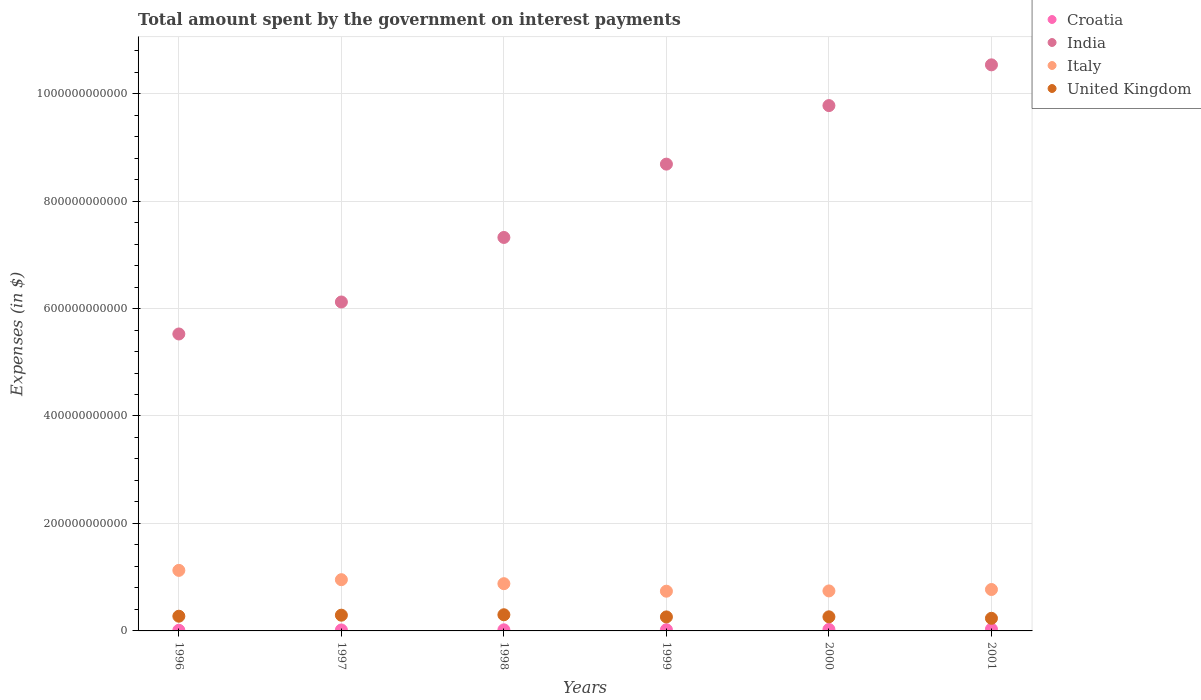Is the number of dotlines equal to the number of legend labels?
Provide a succinct answer. Yes. What is the amount spent on interest payments by the government in Italy in 1999?
Provide a succinct answer. 7.39e+1. Across all years, what is the maximum amount spent on interest payments by the government in Italy?
Your answer should be compact. 1.13e+11. Across all years, what is the minimum amount spent on interest payments by the government in India?
Provide a short and direct response. 5.53e+11. In which year was the amount spent on interest payments by the government in India maximum?
Give a very brief answer. 2001. What is the total amount spent on interest payments by the government in Croatia in the graph?
Make the answer very short. 1.33e+1. What is the difference between the amount spent on interest payments by the government in Italy in 1996 and that in 1998?
Keep it short and to the point. 2.47e+1. What is the difference between the amount spent on interest payments by the government in Croatia in 1997 and the amount spent on interest payments by the government in India in 2000?
Offer a terse response. -9.76e+11. What is the average amount spent on interest payments by the government in United Kingdom per year?
Provide a short and direct response. 2.71e+1. In the year 1996, what is the difference between the amount spent on interest payments by the government in Croatia and amount spent on interest payments by the government in India?
Keep it short and to the point. -5.51e+11. What is the ratio of the amount spent on interest payments by the government in India in 1996 to that in 2000?
Keep it short and to the point. 0.57. Is the amount spent on interest payments by the government in United Kingdom in 1998 less than that in 1999?
Offer a very short reply. No. What is the difference between the highest and the second highest amount spent on interest payments by the government in United Kingdom?
Your answer should be compact. 7.84e+08. What is the difference between the highest and the lowest amount spent on interest payments by the government in Italy?
Make the answer very short. 3.88e+1. Is it the case that in every year, the sum of the amount spent on interest payments by the government in United Kingdom and amount spent on interest payments by the government in Italy  is greater than the amount spent on interest payments by the government in Croatia?
Provide a short and direct response. Yes. Does the amount spent on interest payments by the government in Croatia monotonically increase over the years?
Your response must be concise. Yes. Is the amount spent on interest payments by the government in Italy strictly greater than the amount spent on interest payments by the government in Croatia over the years?
Give a very brief answer. Yes. What is the difference between two consecutive major ticks on the Y-axis?
Offer a terse response. 2.00e+11. Are the values on the major ticks of Y-axis written in scientific E-notation?
Offer a very short reply. No. Does the graph contain any zero values?
Offer a terse response. No. Does the graph contain grids?
Your answer should be very brief. Yes. Where does the legend appear in the graph?
Your response must be concise. Top right. What is the title of the graph?
Provide a short and direct response. Total amount spent by the government on interest payments. What is the label or title of the X-axis?
Your answer should be compact. Years. What is the label or title of the Y-axis?
Make the answer very short. Expenses (in $). What is the Expenses (in $) in Croatia in 1996?
Your answer should be very brief. 1.23e+09. What is the Expenses (in $) in India in 1996?
Offer a terse response. 5.53e+11. What is the Expenses (in $) in Italy in 1996?
Your answer should be very brief. 1.13e+11. What is the Expenses (in $) in United Kingdom in 1996?
Offer a terse response. 2.74e+1. What is the Expenses (in $) of Croatia in 1997?
Make the answer very short. 1.79e+09. What is the Expenses (in $) of India in 1997?
Your response must be concise. 6.12e+11. What is the Expenses (in $) of Italy in 1997?
Ensure brevity in your answer.  9.54e+1. What is the Expenses (in $) of United Kingdom in 1997?
Your response must be concise. 2.93e+1. What is the Expenses (in $) of Croatia in 1998?
Offer a terse response. 2.03e+09. What is the Expenses (in $) in India in 1998?
Your answer should be compact. 7.32e+11. What is the Expenses (in $) of Italy in 1998?
Your answer should be very brief. 8.79e+1. What is the Expenses (in $) in United Kingdom in 1998?
Offer a terse response. 3.01e+1. What is the Expenses (in $) in Croatia in 1999?
Give a very brief answer. 2.23e+09. What is the Expenses (in $) in India in 1999?
Your answer should be very brief. 8.69e+11. What is the Expenses (in $) of Italy in 1999?
Keep it short and to the point. 7.39e+1. What is the Expenses (in $) of United Kingdom in 1999?
Your answer should be compact. 2.61e+1. What is the Expenses (in $) of Croatia in 2000?
Make the answer very short. 2.76e+09. What is the Expenses (in $) of India in 2000?
Make the answer very short. 9.78e+11. What is the Expenses (in $) in Italy in 2000?
Give a very brief answer. 7.44e+1. What is the Expenses (in $) of United Kingdom in 2000?
Offer a terse response. 2.62e+1. What is the Expenses (in $) of Croatia in 2001?
Your answer should be very brief. 3.26e+09. What is the Expenses (in $) of India in 2001?
Provide a short and direct response. 1.05e+12. What is the Expenses (in $) in Italy in 2001?
Offer a very short reply. 7.71e+1. What is the Expenses (in $) in United Kingdom in 2001?
Your answer should be very brief. 2.35e+1. Across all years, what is the maximum Expenses (in $) of Croatia?
Provide a succinct answer. 3.26e+09. Across all years, what is the maximum Expenses (in $) of India?
Your answer should be very brief. 1.05e+12. Across all years, what is the maximum Expenses (in $) of Italy?
Provide a succinct answer. 1.13e+11. Across all years, what is the maximum Expenses (in $) of United Kingdom?
Ensure brevity in your answer.  3.01e+1. Across all years, what is the minimum Expenses (in $) of Croatia?
Give a very brief answer. 1.23e+09. Across all years, what is the minimum Expenses (in $) of India?
Keep it short and to the point. 5.53e+11. Across all years, what is the minimum Expenses (in $) of Italy?
Your response must be concise. 7.39e+1. Across all years, what is the minimum Expenses (in $) in United Kingdom?
Provide a short and direct response. 2.35e+1. What is the total Expenses (in $) in Croatia in the graph?
Make the answer very short. 1.33e+1. What is the total Expenses (in $) in India in the graph?
Your answer should be compact. 4.80e+12. What is the total Expenses (in $) in Italy in the graph?
Offer a terse response. 5.21e+11. What is the total Expenses (in $) of United Kingdom in the graph?
Provide a succinct answer. 1.63e+11. What is the difference between the Expenses (in $) in Croatia in 1996 and that in 1997?
Ensure brevity in your answer.  -5.56e+08. What is the difference between the Expenses (in $) of India in 1996 and that in 1997?
Keep it short and to the point. -5.95e+1. What is the difference between the Expenses (in $) in Italy in 1996 and that in 1997?
Provide a succinct answer. 1.73e+1. What is the difference between the Expenses (in $) in United Kingdom in 1996 and that in 1997?
Keep it short and to the point. -1.93e+09. What is the difference between the Expenses (in $) of Croatia in 1996 and that in 1998?
Provide a succinct answer. -7.92e+08. What is the difference between the Expenses (in $) in India in 1996 and that in 1998?
Keep it short and to the point. -1.80e+11. What is the difference between the Expenses (in $) of Italy in 1996 and that in 1998?
Make the answer very short. 2.47e+1. What is the difference between the Expenses (in $) in United Kingdom in 1996 and that in 1998?
Ensure brevity in your answer.  -2.71e+09. What is the difference between the Expenses (in $) of Croatia in 1996 and that in 1999?
Your answer should be compact. -9.93e+08. What is the difference between the Expenses (in $) of India in 1996 and that in 1999?
Your answer should be compact. -3.16e+11. What is the difference between the Expenses (in $) in Italy in 1996 and that in 1999?
Offer a terse response. 3.88e+1. What is the difference between the Expenses (in $) in United Kingdom in 1996 and that in 1999?
Your answer should be very brief. 1.29e+09. What is the difference between the Expenses (in $) in Croatia in 1996 and that in 2000?
Your answer should be very brief. -1.53e+09. What is the difference between the Expenses (in $) of India in 1996 and that in 2000?
Offer a terse response. -4.25e+11. What is the difference between the Expenses (in $) of Italy in 1996 and that in 2000?
Give a very brief answer. 3.82e+1. What is the difference between the Expenses (in $) of United Kingdom in 1996 and that in 2000?
Make the answer very short. 1.13e+09. What is the difference between the Expenses (in $) of Croatia in 1996 and that in 2001?
Provide a succinct answer. -2.03e+09. What is the difference between the Expenses (in $) of India in 1996 and that in 2001?
Ensure brevity in your answer.  -5.01e+11. What is the difference between the Expenses (in $) of Italy in 1996 and that in 2001?
Offer a very short reply. 3.56e+1. What is the difference between the Expenses (in $) in United Kingdom in 1996 and that in 2001?
Your answer should be very brief. 3.89e+09. What is the difference between the Expenses (in $) in Croatia in 1997 and that in 1998?
Offer a terse response. -2.35e+08. What is the difference between the Expenses (in $) of India in 1997 and that in 1998?
Your answer should be compact. -1.20e+11. What is the difference between the Expenses (in $) in Italy in 1997 and that in 1998?
Keep it short and to the point. 7.42e+09. What is the difference between the Expenses (in $) in United Kingdom in 1997 and that in 1998?
Your answer should be compact. -7.84e+08. What is the difference between the Expenses (in $) in Croatia in 1997 and that in 1999?
Make the answer very short. -4.36e+08. What is the difference between the Expenses (in $) in India in 1997 and that in 1999?
Your response must be concise. -2.57e+11. What is the difference between the Expenses (in $) in Italy in 1997 and that in 1999?
Provide a short and direct response. 2.14e+1. What is the difference between the Expenses (in $) in United Kingdom in 1997 and that in 1999?
Provide a short and direct response. 3.22e+09. What is the difference between the Expenses (in $) of Croatia in 1997 and that in 2000?
Your answer should be very brief. -9.73e+08. What is the difference between the Expenses (in $) of India in 1997 and that in 2000?
Your response must be concise. -3.66e+11. What is the difference between the Expenses (in $) of Italy in 1997 and that in 2000?
Keep it short and to the point. 2.09e+1. What is the difference between the Expenses (in $) in United Kingdom in 1997 and that in 2000?
Ensure brevity in your answer.  3.06e+09. What is the difference between the Expenses (in $) in Croatia in 1997 and that in 2001?
Ensure brevity in your answer.  -1.47e+09. What is the difference between the Expenses (in $) in India in 1997 and that in 2001?
Give a very brief answer. -4.41e+11. What is the difference between the Expenses (in $) of Italy in 1997 and that in 2001?
Ensure brevity in your answer.  1.83e+1. What is the difference between the Expenses (in $) of United Kingdom in 1997 and that in 2001?
Provide a short and direct response. 5.82e+09. What is the difference between the Expenses (in $) of Croatia in 1998 and that in 1999?
Offer a very short reply. -2.01e+08. What is the difference between the Expenses (in $) in India in 1998 and that in 1999?
Provide a short and direct response. -1.36e+11. What is the difference between the Expenses (in $) of Italy in 1998 and that in 1999?
Your answer should be compact. 1.40e+1. What is the difference between the Expenses (in $) in United Kingdom in 1998 and that in 1999?
Ensure brevity in your answer.  4.01e+09. What is the difference between the Expenses (in $) in Croatia in 1998 and that in 2000?
Provide a short and direct response. -7.38e+08. What is the difference between the Expenses (in $) of India in 1998 and that in 2000?
Give a very brief answer. -2.45e+11. What is the difference between the Expenses (in $) of Italy in 1998 and that in 2000?
Your answer should be compact. 1.35e+1. What is the difference between the Expenses (in $) of United Kingdom in 1998 and that in 2000?
Provide a short and direct response. 3.84e+09. What is the difference between the Expenses (in $) of Croatia in 1998 and that in 2001?
Your answer should be compact. -1.23e+09. What is the difference between the Expenses (in $) in India in 1998 and that in 2001?
Give a very brief answer. -3.21e+11. What is the difference between the Expenses (in $) in Italy in 1998 and that in 2001?
Offer a very short reply. 1.09e+1. What is the difference between the Expenses (in $) of United Kingdom in 1998 and that in 2001?
Your answer should be very brief. 6.60e+09. What is the difference between the Expenses (in $) in Croatia in 1999 and that in 2000?
Provide a short and direct response. -5.37e+08. What is the difference between the Expenses (in $) of India in 1999 and that in 2000?
Your answer should be compact. -1.09e+11. What is the difference between the Expenses (in $) of Italy in 1999 and that in 2000?
Give a very brief answer. -5.15e+08. What is the difference between the Expenses (in $) of United Kingdom in 1999 and that in 2000?
Your response must be concise. -1.66e+08. What is the difference between the Expenses (in $) in Croatia in 1999 and that in 2001?
Ensure brevity in your answer.  -1.03e+09. What is the difference between the Expenses (in $) of India in 1999 and that in 2001?
Keep it short and to the point. -1.85e+11. What is the difference between the Expenses (in $) of Italy in 1999 and that in 2001?
Keep it short and to the point. -3.14e+09. What is the difference between the Expenses (in $) of United Kingdom in 1999 and that in 2001?
Make the answer very short. 2.60e+09. What is the difference between the Expenses (in $) of Croatia in 2000 and that in 2001?
Provide a short and direct response. -4.96e+08. What is the difference between the Expenses (in $) of India in 2000 and that in 2001?
Ensure brevity in your answer.  -7.58e+1. What is the difference between the Expenses (in $) in Italy in 2000 and that in 2001?
Offer a terse response. -2.63e+09. What is the difference between the Expenses (in $) in United Kingdom in 2000 and that in 2001?
Give a very brief answer. 2.76e+09. What is the difference between the Expenses (in $) in Croatia in 1996 and the Expenses (in $) in India in 1997?
Offer a very short reply. -6.11e+11. What is the difference between the Expenses (in $) of Croatia in 1996 and the Expenses (in $) of Italy in 1997?
Give a very brief answer. -9.41e+1. What is the difference between the Expenses (in $) in Croatia in 1996 and the Expenses (in $) in United Kingdom in 1997?
Ensure brevity in your answer.  -2.81e+1. What is the difference between the Expenses (in $) of India in 1996 and the Expenses (in $) of Italy in 1997?
Provide a succinct answer. 4.57e+11. What is the difference between the Expenses (in $) in India in 1996 and the Expenses (in $) in United Kingdom in 1997?
Offer a terse response. 5.23e+11. What is the difference between the Expenses (in $) of Italy in 1996 and the Expenses (in $) of United Kingdom in 1997?
Ensure brevity in your answer.  8.34e+1. What is the difference between the Expenses (in $) in Croatia in 1996 and the Expenses (in $) in India in 1998?
Ensure brevity in your answer.  -7.31e+11. What is the difference between the Expenses (in $) of Croatia in 1996 and the Expenses (in $) of Italy in 1998?
Your response must be concise. -8.67e+1. What is the difference between the Expenses (in $) of Croatia in 1996 and the Expenses (in $) of United Kingdom in 1998?
Provide a succinct answer. -2.88e+1. What is the difference between the Expenses (in $) of India in 1996 and the Expenses (in $) of Italy in 1998?
Your answer should be compact. 4.65e+11. What is the difference between the Expenses (in $) of India in 1996 and the Expenses (in $) of United Kingdom in 1998?
Offer a terse response. 5.23e+11. What is the difference between the Expenses (in $) in Italy in 1996 and the Expenses (in $) in United Kingdom in 1998?
Offer a terse response. 8.26e+1. What is the difference between the Expenses (in $) of Croatia in 1996 and the Expenses (in $) of India in 1999?
Offer a terse response. -8.68e+11. What is the difference between the Expenses (in $) in Croatia in 1996 and the Expenses (in $) in Italy in 1999?
Your answer should be compact. -7.27e+1. What is the difference between the Expenses (in $) in Croatia in 1996 and the Expenses (in $) in United Kingdom in 1999?
Your answer should be compact. -2.48e+1. What is the difference between the Expenses (in $) of India in 1996 and the Expenses (in $) of Italy in 1999?
Offer a very short reply. 4.79e+11. What is the difference between the Expenses (in $) in India in 1996 and the Expenses (in $) in United Kingdom in 1999?
Your answer should be compact. 5.27e+11. What is the difference between the Expenses (in $) of Italy in 1996 and the Expenses (in $) of United Kingdom in 1999?
Give a very brief answer. 8.66e+1. What is the difference between the Expenses (in $) in Croatia in 1996 and the Expenses (in $) in India in 2000?
Ensure brevity in your answer.  -9.76e+11. What is the difference between the Expenses (in $) in Croatia in 1996 and the Expenses (in $) in Italy in 2000?
Provide a succinct answer. -7.32e+1. What is the difference between the Expenses (in $) in Croatia in 1996 and the Expenses (in $) in United Kingdom in 2000?
Provide a succinct answer. -2.50e+1. What is the difference between the Expenses (in $) of India in 1996 and the Expenses (in $) of Italy in 2000?
Provide a short and direct response. 4.78e+11. What is the difference between the Expenses (in $) in India in 1996 and the Expenses (in $) in United Kingdom in 2000?
Ensure brevity in your answer.  5.26e+11. What is the difference between the Expenses (in $) in Italy in 1996 and the Expenses (in $) in United Kingdom in 2000?
Ensure brevity in your answer.  8.64e+1. What is the difference between the Expenses (in $) in Croatia in 1996 and the Expenses (in $) in India in 2001?
Offer a very short reply. -1.05e+12. What is the difference between the Expenses (in $) in Croatia in 1996 and the Expenses (in $) in Italy in 2001?
Make the answer very short. -7.58e+1. What is the difference between the Expenses (in $) in Croatia in 1996 and the Expenses (in $) in United Kingdom in 2001?
Ensure brevity in your answer.  -2.22e+1. What is the difference between the Expenses (in $) of India in 1996 and the Expenses (in $) of Italy in 2001?
Give a very brief answer. 4.76e+11. What is the difference between the Expenses (in $) of India in 1996 and the Expenses (in $) of United Kingdom in 2001?
Your answer should be compact. 5.29e+11. What is the difference between the Expenses (in $) in Italy in 1996 and the Expenses (in $) in United Kingdom in 2001?
Offer a terse response. 8.92e+1. What is the difference between the Expenses (in $) of Croatia in 1997 and the Expenses (in $) of India in 1998?
Offer a very short reply. -7.30e+11. What is the difference between the Expenses (in $) of Croatia in 1997 and the Expenses (in $) of Italy in 1998?
Offer a terse response. -8.61e+1. What is the difference between the Expenses (in $) in Croatia in 1997 and the Expenses (in $) in United Kingdom in 1998?
Provide a succinct answer. -2.83e+1. What is the difference between the Expenses (in $) in India in 1997 and the Expenses (in $) in Italy in 1998?
Make the answer very short. 5.24e+11. What is the difference between the Expenses (in $) of India in 1997 and the Expenses (in $) of United Kingdom in 1998?
Offer a terse response. 5.82e+11. What is the difference between the Expenses (in $) in Italy in 1997 and the Expenses (in $) in United Kingdom in 1998?
Provide a succinct answer. 6.53e+1. What is the difference between the Expenses (in $) in Croatia in 1997 and the Expenses (in $) in India in 1999?
Give a very brief answer. -8.67e+11. What is the difference between the Expenses (in $) in Croatia in 1997 and the Expenses (in $) in Italy in 1999?
Give a very brief answer. -7.21e+1. What is the difference between the Expenses (in $) in Croatia in 1997 and the Expenses (in $) in United Kingdom in 1999?
Your answer should be very brief. -2.43e+1. What is the difference between the Expenses (in $) in India in 1997 and the Expenses (in $) in Italy in 1999?
Your answer should be very brief. 5.38e+11. What is the difference between the Expenses (in $) of India in 1997 and the Expenses (in $) of United Kingdom in 1999?
Your response must be concise. 5.86e+11. What is the difference between the Expenses (in $) in Italy in 1997 and the Expenses (in $) in United Kingdom in 1999?
Keep it short and to the point. 6.93e+1. What is the difference between the Expenses (in $) of Croatia in 1997 and the Expenses (in $) of India in 2000?
Keep it short and to the point. -9.76e+11. What is the difference between the Expenses (in $) of Croatia in 1997 and the Expenses (in $) of Italy in 2000?
Ensure brevity in your answer.  -7.26e+1. What is the difference between the Expenses (in $) in Croatia in 1997 and the Expenses (in $) in United Kingdom in 2000?
Your answer should be very brief. -2.44e+1. What is the difference between the Expenses (in $) in India in 1997 and the Expenses (in $) in Italy in 2000?
Your response must be concise. 5.38e+11. What is the difference between the Expenses (in $) of India in 1997 and the Expenses (in $) of United Kingdom in 2000?
Provide a short and direct response. 5.86e+11. What is the difference between the Expenses (in $) in Italy in 1997 and the Expenses (in $) in United Kingdom in 2000?
Keep it short and to the point. 6.91e+1. What is the difference between the Expenses (in $) in Croatia in 1997 and the Expenses (in $) in India in 2001?
Offer a very short reply. -1.05e+12. What is the difference between the Expenses (in $) of Croatia in 1997 and the Expenses (in $) of Italy in 2001?
Your answer should be very brief. -7.53e+1. What is the difference between the Expenses (in $) in Croatia in 1997 and the Expenses (in $) in United Kingdom in 2001?
Offer a terse response. -2.17e+1. What is the difference between the Expenses (in $) of India in 1997 and the Expenses (in $) of Italy in 2001?
Provide a short and direct response. 5.35e+11. What is the difference between the Expenses (in $) of India in 1997 and the Expenses (in $) of United Kingdom in 2001?
Your response must be concise. 5.89e+11. What is the difference between the Expenses (in $) in Italy in 1997 and the Expenses (in $) in United Kingdom in 2001?
Provide a short and direct response. 7.19e+1. What is the difference between the Expenses (in $) of Croatia in 1998 and the Expenses (in $) of India in 1999?
Offer a terse response. -8.67e+11. What is the difference between the Expenses (in $) in Croatia in 1998 and the Expenses (in $) in Italy in 1999?
Your answer should be very brief. -7.19e+1. What is the difference between the Expenses (in $) of Croatia in 1998 and the Expenses (in $) of United Kingdom in 1999?
Your answer should be very brief. -2.40e+1. What is the difference between the Expenses (in $) of India in 1998 and the Expenses (in $) of Italy in 1999?
Your answer should be very brief. 6.58e+11. What is the difference between the Expenses (in $) of India in 1998 and the Expenses (in $) of United Kingdom in 1999?
Provide a short and direct response. 7.06e+11. What is the difference between the Expenses (in $) in Italy in 1998 and the Expenses (in $) in United Kingdom in 1999?
Your response must be concise. 6.19e+1. What is the difference between the Expenses (in $) in Croatia in 1998 and the Expenses (in $) in India in 2000?
Keep it short and to the point. -9.76e+11. What is the difference between the Expenses (in $) in Croatia in 1998 and the Expenses (in $) in Italy in 2000?
Ensure brevity in your answer.  -7.24e+1. What is the difference between the Expenses (in $) of Croatia in 1998 and the Expenses (in $) of United Kingdom in 2000?
Provide a succinct answer. -2.42e+1. What is the difference between the Expenses (in $) in India in 1998 and the Expenses (in $) in Italy in 2000?
Keep it short and to the point. 6.58e+11. What is the difference between the Expenses (in $) of India in 1998 and the Expenses (in $) of United Kingdom in 2000?
Ensure brevity in your answer.  7.06e+11. What is the difference between the Expenses (in $) in Italy in 1998 and the Expenses (in $) in United Kingdom in 2000?
Provide a short and direct response. 6.17e+1. What is the difference between the Expenses (in $) of Croatia in 1998 and the Expenses (in $) of India in 2001?
Make the answer very short. -1.05e+12. What is the difference between the Expenses (in $) in Croatia in 1998 and the Expenses (in $) in Italy in 2001?
Your response must be concise. -7.50e+1. What is the difference between the Expenses (in $) in Croatia in 1998 and the Expenses (in $) in United Kingdom in 2001?
Your answer should be very brief. -2.14e+1. What is the difference between the Expenses (in $) of India in 1998 and the Expenses (in $) of Italy in 2001?
Keep it short and to the point. 6.55e+11. What is the difference between the Expenses (in $) in India in 1998 and the Expenses (in $) in United Kingdom in 2001?
Provide a short and direct response. 7.09e+11. What is the difference between the Expenses (in $) of Italy in 1998 and the Expenses (in $) of United Kingdom in 2001?
Your answer should be very brief. 6.45e+1. What is the difference between the Expenses (in $) of Croatia in 1999 and the Expenses (in $) of India in 2000?
Make the answer very short. -9.75e+11. What is the difference between the Expenses (in $) in Croatia in 1999 and the Expenses (in $) in Italy in 2000?
Your answer should be compact. -7.22e+1. What is the difference between the Expenses (in $) of Croatia in 1999 and the Expenses (in $) of United Kingdom in 2000?
Your response must be concise. -2.40e+1. What is the difference between the Expenses (in $) in India in 1999 and the Expenses (in $) in Italy in 2000?
Give a very brief answer. 7.94e+11. What is the difference between the Expenses (in $) in India in 1999 and the Expenses (in $) in United Kingdom in 2000?
Your answer should be very brief. 8.43e+11. What is the difference between the Expenses (in $) of Italy in 1999 and the Expenses (in $) of United Kingdom in 2000?
Your response must be concise. 4.77e+1. What is the difference between the Expenses (in $) in Croatia in 1999 and the Expenses (in $) in India in 2001?
Provide a short and direct response. -1.05e+12. What is the difference between the Expenses (in $) of Croatia in 1999 and the Expenses (in $) of Italy in 2001?
Keep it short and to the point. -7.48e+1. What is the difference between the Expenses (in $) in Croatia in 1999 and the Expenses (in $) in United Kingdom in 2001?
Make the answer very short. -2.12e+1. What is the difference between the Expenses (in $) of India in 1999 and the Expenses (in $) of Italy in 2001?
Keep it short and to the point. 7.92e+11. What is the difference between the Expenses (in $) in India in 1999 and the Expenses (in $) in United Kingdom in 2001?
Give a very brief answer. 8.45e+11. What is the difference between the Expenses (in $) of Italy in 1999 and the Expenses (in $) of United Kingdom in 2001?
Your response must be concise. 5.04e+1. What is the difference between the Expenses (in $) of Croatia in 2000 and the Expenses (in $) of India in 2001?
Your response must be concise. -1.05e+12. What is the difference between the Expenses (in $) of Croatia in 2000 and the Expenses (in $) of Italy in 2001?
Ensure brevity in your answer.  -7.43e+1. What is the difference between the Expenses (in $) in Croatia in 2000 and the Expenses (in $) in United Kingdom in 2001?
Your response must be concise. -2.07e+1. What is the difference between the Expenses (in $) of India in 2000 and the Expenses (in $) of Italy in 2001?
Your response must be concise. 9.01e+11. What is the difference between the Expenses (in $) in India in 2000 and the Expenses (in $) in United Kingdom in 2001?
Provide a short and direct response. 9.54e+11. What is the difference between the Expenses (in $) in Italy in 2000 and the Expenses (in $) in United Kingdom in 2001?
Make the answer very short. 5.10e+1. What is the average Expenses (in $) in Croatia per year?
Keep it short and to the point. 2.22e+09. What is the average Expenses (in $) in India per year?
Offer a very short reply. 8.00e+11. What is the average Expenses (in $) of Italy per year?
Make the answer very short. 8.69e+1. What is the average Expenses (in $) in United Kingdom per year?
Your response must be concise. 2.71e+1. In the year 1996, what is the difference between the Expenses (in $) of Croatia and Expenses (in $) of India?
Your answer should be very brief. -5.51e+11. In the year 1996, what is the difference between the Expenses (in $) of Croatia and Expenses (in $) of Italy?
Your answer should be very brief. -1.11e+11. In the year 1996, what is the difference between the Expenses (in $) of Croatia and Expenses (in $) of United Kingdom?
Ensure brevity in your answer.  -2.61e+1. In the year 1996, what is the difference between the Expenses (in $) of India and Expenses (in $) of Italy?
Your response must be concise. 4.40e+11. In the year 1996, what is the difference between the Expenses (in $) of India and Expenses (in $) of United Kingdom?
Keep it short and to the point. 5.25e+11. In the year 1996, what is the difference between the Expenses (in $) of Italy and Expenses (in $) of United Kingdom?
Your answer should be very brief. 8.53e+1. In the year 1997, what is the difference between the Expenses (in $) in Croatia and Expenses (in $) in India?
Keep it short and to the point. -6.10e+11. In the year 1997, what is the difference between the Expenses (in $) in Croatia and Expenses (in $) in Italy?
Offer a terse response. -9.36e+1. In the year 1997, what is the difference between the Expenses (in $) of Croatia and Expenses (in $) of United Kingdom?
Make the answer very short. -2.75e+1. In the year 1997, what is the difference between the Expenses (in $) of India and Expenses (in $) of Italy?
Give a very brief answer. 5.17e+11. In the year 1997, what is the difference between the Expenses (in $) in India and Expenses (in $) in United Kingdom?
Your answer should be very brief. 5.83e+11. In the year 1997, what is the difference between the Expenses (in $) of Italy and Expenses (in $) of United Kingdom?
Your response must be concise. 6.61e+1. In the year 1998, what is the difference between the Expenses (in $) in Croatia and Expenses (in $) in India?
Keep it short and to the point. -7.30e+11. In the year 1998, what is the difference between the Expenses (in $) in Croatia and Expenses (in $) in Italy?
Keep it short and to the point. -8.59e+1. In the year 1998, what is the difference between the Expenses (in $) in Croatia and Expenses (in $) in United Kingdom?
Give a very brief answer. -2.81e+1. In the year 1998, what is the difference between the Expenses (in $) of India and Expenses (in $) of Italy?
Offer a terse response. 6.44e+11. In the year 1998, what is the difference between the Expenses (in $) of India and Expenses (in $) of United Kingdom?
Ensure brevity in your answer.  7.02e+11. In the year 1998, what is the difference between the Expenses (in $) in Italy and Expenses (in $) in United Kingdom?
Your response must be concise. 5.79e+1. In the year 1999, what is the difference between the Expenses (in $) of Croatia and Expenses (in $) of India?
Offer a terse response. -8.67e+11. In the year 1999, what is the difference between the Expenses (in $) in Croatia and Expenses (in $) in Italy?
Offer a very short reply. -7.17e+1. In the year 1999, what is the difference between the Expenses (in $) in Croatia and Expenses (in $) in United Kingdom?
Your answer should be very brief. -2.38e+1. In the year 1999, what is the difference between the Expenses (in $) in India and Expenses (in $) in Italy?
Your answer should be compact. 7.95e+11. In the year 1999, what is the difference between the Expenses (in $) in India and Expenses (in $) in United Kingdom?
Your answer should be very brief. 8.43e+11. In the year 1999, what is the difference between the Expenses (in $) in Italy and Expenses (in $) in United Kingdom?
Your response must be concise. 4.79e+1. In the year 2000, what is the difference between the Expenses (in $) in Croatia and Expenses (in $) in India?
Your answer should be very brief. -9.75e+11. In the year 2000, what is the difference between the Expenses (in $) of Croatia and Expenses (in $) of Italy?
Offer a very short reply. -7.17e+1. In the year 2000, what is the difference between the Expenses (in $) in Croatia and Expenses (in $) in United Kingdom?
Offer a terse response. -2.35e+1. In the year 2000, what is the difference between the Expenses (in $) of India and Expenses (in $) of Italy?
Your answer should be very brief. 9.03e+11. In the year 2000, what is the difference between the Expenses (in $) in India and Expenses (in $) in United Kingdom?
Keep it short and to the point. 9.51e+11. In the year 2000, what is the difference between the Expenses (in $) of Italy and Expenses (in $) of United Kingdom?
Offer a very short reply. 4.82e+1. In the year 2001, what is the difference between the Expenses (in $) in Croatia and Expenses (in $) in India?
Offer a terse response. -1.05e+12. In the year 2001, what is the difference between the Expenses (in $) in Croatia and Expenses (in $) in Italy?
Offer a very short reply. -7.38e+1. In the year 2001, what is the difference between the Expenses (in $) in Croatia and Expenses (in $) in United Kingdom?
Offer a very short reply. -2.02e+1. In the year 2001, what is the difference between the Expenses (in $) of India and Expenses (in $) of Italy?
Give a very brief answer. 9.76e+11. In the year 2001, what is the difference between the Expenses (in $) of India and Expenses (in $) of United Kingdom?
Your response must be concise. 1.03e+12. In the year 2001, what is the difference between the Expenses (in $) of Italy and Expenses (in $) of United Kingdom?
Provide a short and direct response. 5.36e+1. What is the ratio of the Expenses (in $) of Croatia in 1996 to that in 1997?
Make the answer very short. 0.69. What is the ratio of the Expenses (in $) of India in 1996 to that in 1997?
Provide a succinct answer. 0.9. What is the ratio of the Expenses (in $) in Italy in 1996 to that in 1997?
Provide a succinct answer. 1.18. What is the ratio of the Expenses (in $) in United Kingdom in 1996 to that in 1997?
Your response must be concise. 0.93. What is the ratio of the Expenses (in $) in Croatia in 1996 to that in 1998?
Offer a terse response. 0.61. What is the ratio of the Expenses (in $) in India in 1996 to that in 1998?
Make the answer very short. 0.75. What is the ratio of the Expenses (in $) in Italy in 1996 to that in 1998?
Keep it short and to the point. 1.28. What is the ratio of the Expenses (in $) of United Kingdom in 1996 to that in 1998?
Offer a terse response. 0.91. What is the ratio of the Expenses (in $) of Croatia in 1996 to that in 1999?
Offer a terse response. 0.55. What is the ratio of the Expenses (in $) in India in 1996 to that in 1999?
Provide a short and direct response. 0.64. What is the ratio of the Expenses (in $) of Italy in 1996 to that in 1999?
Ensure brevity in your answer.  1.52. What is the ratio of the Expenses (in $) in United Kingdom in 1996 to that in 1999?
Make the answer very short. 1.05. What is the ratio of the Expenses (in $) of Croatia in 1996 to that in 2000?
Ensure brevity in your answer.  0.45. What is the ratio of the Expenses (in $) in India in 1996 to that in 2000?
Your answer should be very brief. 0.57. What is the ratio of the Expenses (in $) of Italy in 1996 to that in 2000?
Ensure brevity in your answer.  1.51. What is the ratio of the Expenses (in $) of United Kingdom in 1996 to that in 2000?
Make the answer very short. 1.04. What is the ratio of the Expenses (in $) in Croatia in 1996 to that in 2001?
Ensure brevity in your answer.  0.38. What is the ratio of the Expenses (in $) of India in 1996 to that in 2001?
Your answer should be very brief. 0.52. What is the ratio of the Expenses (in $) in Italy in 1996 to that in 2001?
Your answer should be compact. 1.46. What is the ratio of the Expenses (in $) of United Kingdom in 1996 to that in 2001?
Keep it short and to the point. 1.17. What is the ratio of the Expenses (in $) in Croatia in 1997 to that in 1998?
Offer a terse response. 0.88. What is the ratio of the Expenses (in $) in India in 1997 to that in 1998?
Give a very brief answer. 0.84. What is the ratio of the Expenses (in $) in Italy in 1997 to that in 1998?
Your answer should be compact. 1.08. What is the ratio of the Expenses (in $) of United Kingdom in 1997 to that in 1998?
Offer a very short reply. 0.97. What is the ratio of the Expenses (in $) of Croatia in 1997 to that in 1999?
Your answer should be compact. 0.8. What is the ratio of the Expenses (in $) of India in 1997 to that in 1999?
Provide a short and direct response. 0.7. What is the ratio of the Expenses (in $) in Italy in 1997 to that in 1999?
Offer a very short reply. 1.29. What is the ratio of the Expenses (in $) of United Kingdom in 1997 to that in 1999?
Give a very brief answer. 1.12. What is the ratio of the Expenses (in $) of Croatia in 1997 to that in 2000?
Provide a short and direct response. 0.65. What is the ratio of the Expenses (in $) of India in 1997 to that in 2000?
Offer a very short reply. 0.63. What is the ratio of the Expenses (in $) of Italy in 1997 to that in 2000?
Your answer should be very brief. 1.28. What is the ratio of the Expenses (in $) in United Kingdom in 1997 to that in 2000?
Provide a short and direct response. 1.12. What is the ratio of the Expenses (in $) in Croatia in 1997 to that in 2001?
Your answer should be very brief. 0.55. What is the ratio of the Expenses (in $) of India in 1997 to that in 2001?
Keep it short and to the point. 0.58. What is the ratio of the Expenses (in $) in Italy in 1997 to that in 2001?
Ensure brevity in your answer.  1.24. What is the ratio of the Expenses (in $) in United Kingdom in 1997 to that in 2001?
Keep it short and to the point. 1.25. What is the ratio of the Expenses (in $) in Croatia in 1998 to that in 1999?
Your response must be concise. 0.91. What is the ratio of the Expenses (in $) of India in 1998 to that in 1999?
Your answer should be very brief. 0.84. What is the ratio of the Expenses (in $) in Italy in 1998 to that in 1999?
Keep it short and to the point. 1.19. What is the ratio of the Expenses (in $) in United Kingdom in 1998 to that in 1999?
Make the answer very short. 1.15. What is the ratio of the Expenses (in $) in Croatia in 1998 to that in 2000?
Ensure brevity in your answer.  0.73. What is the ratio of the Expenses (in $) in India in 1998 to that in 2000?
Give a very brief answer. 0.75. What is the ratio of the Expenses (in $) in Italy in 1998 to that in 2000?
Provide a succinct answer. 1.18. What is the ratio of the Expenses (in $) in United Kingdom in 1998 to that in 2000?
Give a very brief answer. 1.15. What is the ratio of the Expenses (in $) of Croatia in 1998 to that in 2001?
Your answer should be compact. 0.62. What is the ratio of the Expenses (in $) of India in 1998 to that in 2001?
Your response must be concise. 0.7. What is the ratio of the Expenses (in $) in Italy in 1998 to that in 2001?
Offer a terse response. 1.14. What is the ratio of the Expenses (in $) of United Kingdom in 1998 to that in 2001?
Offer a very short reply. 1.28. What is the ratio of the Expenses (in $) in Croatia in 1999 to that in 2000?
Make the answer very short. 0.81. What is the ratio of the Expenses (in $) in India in 1999 to that in 2000?
Make the answer very short. 0.89. What is the ratio of the Expenses (in $) in Italy in 1999 to that in 2000?
Provide a succinct answer. 0.99. What is the ratio of the Expenses (in $) in Croatia in 1999 to that in 2001?
Your response must be concise. 0.68. What is the ratio of the Expenses (in $) in India in 1999 to that in 2001?
Offer a terse response. 0.82. What is the ratio of the Expenses (in $) of Italy in 1999 to that in 2001?
Make the answer very short. 0.96. What is the ratio of the Expenses (in $) of United Kingdom in 1999 to that in 2001?
Your response must be concise. 1.11. What is the ratio of the Expenses (in $) of Croatia in 2000 to that in 2001?
Make the answer very short. 0.85. What is the ratio of the Expenses (in $) of India in 2000 to that in 2001?
Keep it short and to the point. 0.93. What is the ratio of the Expenses (in $) in Italy in 2000 to that in 2001?
Keep it short and to the point. 0.97. What is the ratio of the Expenses (in $) in United Kingdom in 2000 to that in 2001?
Give a very brief answer. 1.12. What is the difference between the highest and the second highest Expenses (in $) of Croatia?
Offer a terse response. 4.96e+08. What is the difference between the highest and the second highest Expenses (in $) of India?
Keep it short and to the point. 7.58e+1. What is the difference between the highest and the second highest Expenses (in $) of Italy?
Ensure brevity in your answer.  1.73e+1. What is the difference between the highest and the second highest Expenses (in $) in United Kingdom?
Make the answer very short. 7.84e+08. What is the difference between the highest and the lowest Expenses (in $) of Croatia?
Offer a very short reply. 2.03e+09. What is the difference between the highest and the lowest Expenses (in $) in India?
Your answer should be very brief. 5.01e+11. What is the difference between the highest and the lowest Expenses (in $) in Italy?
Give a very brief answer. 3.88e+1. What is the difference between the highest and the lowest Expenses (in $) in United Kingdom?
Ensure brevity in your answer.  6.60e+09. 